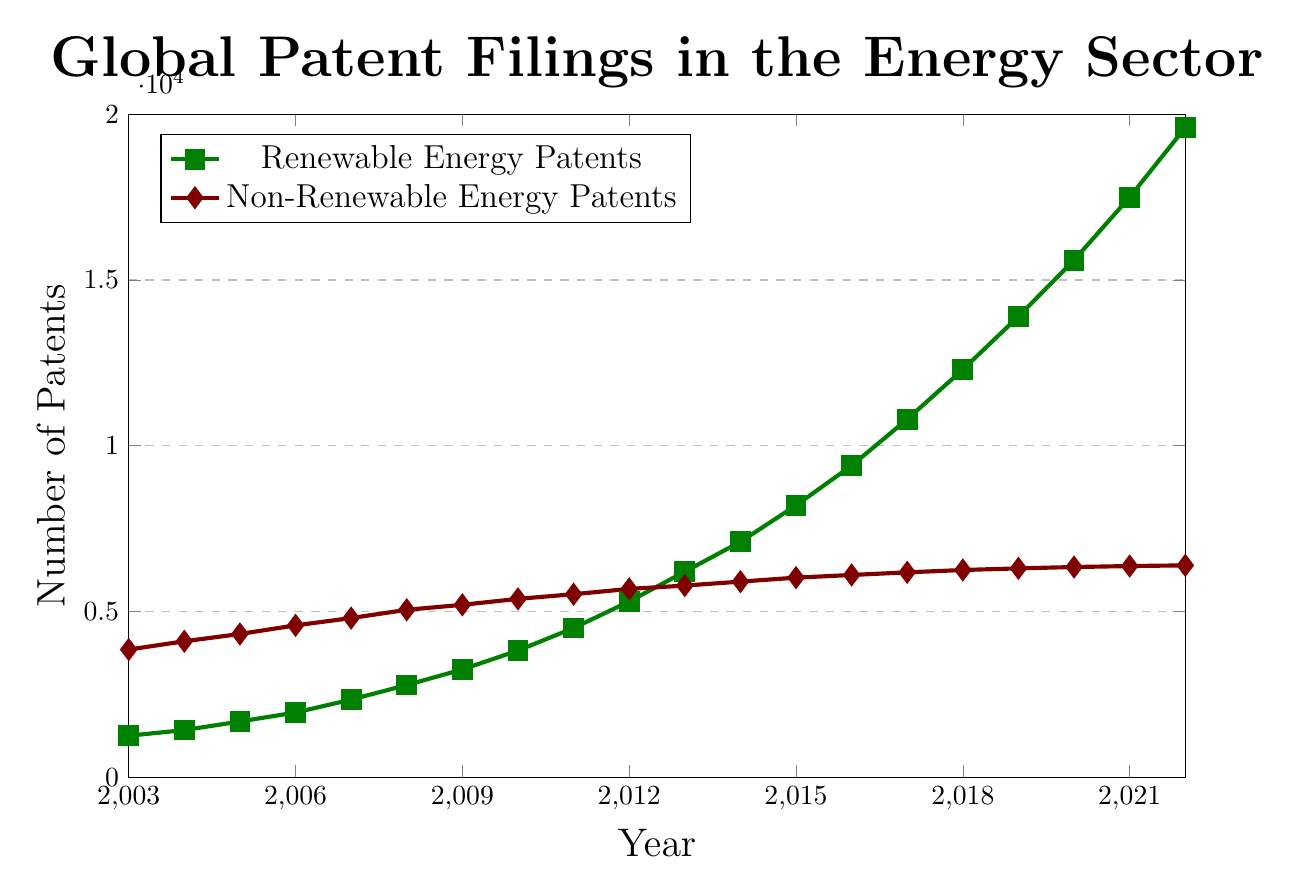What is the trend in the number of renewable energy patents over the past 20 years? From 2003 to 2022, the number of renewable energy patents has steadily increased every year. Starting from 1,250 in 2003, it has grown to 19,600 in 2022.
Answer: Steady increase How does the number of non-renewable energy patents in 2003 compare to the number in 2022? In 2003, the number of non-renewable energy patents was 3,850. By 2022, this number increased to 6,390. This indicates that there was an increase over the 20-year period.
Answer: Increased Which year saw the highest number of renewable energy patents filed? The maximum number of renewable energy patents filed was in 2022, with 19,600 patents.
Answer: 2022 In which year did renewable energy patents first surpass 10,000? The number of renewable energy patents first surpassed 10,000 in 2017, with 10,800 patents filed that year.
Answer: 2017 Was there any year when the number of non-renewable energy patents decreased compared to the previous year? No, there was no year when the number of non-renewable energy patents decreased compared to the previous year. It consistently increased, although the rate of increase varied.
Answer: No What is the average number of renewable energy patents filed per year from 2003 to 2022? Sum of the renewable energy patents from 2003 to 2022 is 1,250 + 1,420 + 1,680 + 1,950 + 2,340 + 2,780 + 3,250 + 3,820 + 4,500 + 5,300 + 6,200 + 7,100 + 8,200 + 9,400 + 10,800 + 12,300 + 13,900 + 15,600 + 17,500 + 19,600 = 152,790. The average is 152,790 / 20 = 7,639.5.
Answer: 7,639.5 Which category, renewable or non-renewable energy, saw a higher rate of increase in patent filings over the 20-year period? Renewable energy patents increased from 1,250 in 2003 to 19,600 in 2022, a difference of 18,350. Non-renewable energy patents increased from 3,850 in 2003 to 6,390 in 2022, a difference of 2,540. Thus, renewable energy saw a higher rate of increase.
Answer: Renewable What is the difference between the number of renewable and non-renewable energy patents filed in 2022? In 2022, renewable energy patents were 19,600 and non-renewable energy patents were 6,390. The difference is 19,600 - 6,390 = 13,210.
Answer: 13,210 How does the visual representation highlight the growth trend between renewable and non-renewable energy patents? The green line marking renewable energy patents shows a consistent upward trend with larger slopes, indicating rapid growth. The red line for non-renewable energy patents shows a slower rate of increase with smaller slopes.
Answer: Faster growth for renewable What is the average annual increase in renewable energy patents from 2003 to 2022? The total increase in renewable energy patents from 2003 (1,250) to 2022 (19,600) is 18,350. Over 19 years, the average annual increase is 18,350 / 19 ≈ 965.79.
Answer: 965.79 